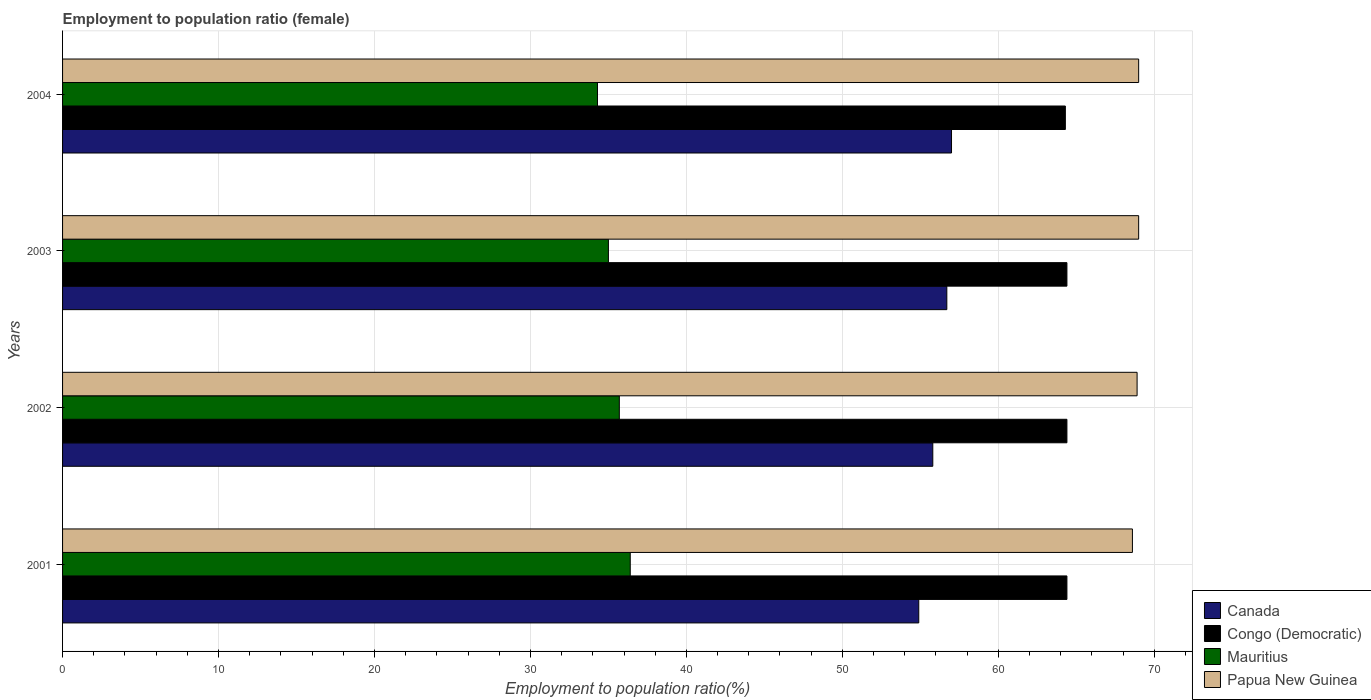How many different coloured bars are there?
Offer a very short reply. 4. Are the number of bars per tick equal to the number of legend labels?
Make the answer very short. Yes. Are the number of bars on each tick of the Y-axis equal?
Give a very brief answer. Yes. How many bars are there on the 2nd tick from the top?
Your answer should be compact. 4. How many bars are there on the 4th tick from the bottom?
Your answer should be compact. 4. What is the label of the 3rd group of bars from the top?
Provide a short and direct response. 2002. In how many cases, is the number of bars for a given year not equal to the number of legend labels?
Give a very brief answer. 0. What is the employment to population ratio in Papua New Guinea in 2001?
Provide a short and direct response. 68.6. Across all years, what is the maximum employment to population ratio in Mauritius?
Provide a short and direct response. 36.4. Across all years, what is the minimum employment to population ratio in Papua New Guinea?
Your answer should be very brief. 68.6. What is the total employment to population ratio in Papua New Guinea in the graph?
Your answer should be very brief. 275.5. What is the difference between the employment to population ratio in Papua New Guinea in 2003 and that in 2004?
Ensure brevity in your answer.  0. What is the difference between the employment to population ratio in Papua New Guinea in 2001 and the employment to population ratio in Canada in 2003?
Your response must be concise. 11.9. What is the average employment to population ratio in Congo (Democratic) per year?
Your response must be concise. 64.38. In the year 2003, what is the difference between the employment to population ratio in Canada and employment to population ratio in Mauritius?
Give a very brief answer. 21.7. What is the ratio of the employment to population ratio in Congo (Democratic) in 2002 to that in 2003?
Make the answer very short. 1. What is the difference between the highest and the second highest employment to population ratio in Canada?
Your answer should be compact. 0.3. What is the difference between the highest and the lowest employment to population ratio in Papua New Guinea?
Your answer should be very brief. 0.4. In how many years, is the employment to population ratio in Papua New Guinea greater than the average employment to population ratio in Papua New Guinea taken over all years?
Offer a terse response. 3. Is it the case that in every year, the sum of the employment to population ratio in Congo (Democratic) and employment to population ratio in Mauritius is greater than the sum of employment to population ratio in Canada and employment to population ratio in Papua New Guinea?
Your answer should be very brief. Yes. What does the 2nd bar from the top in 2004 represents?
Provide a succinct answer. Mauritius. What does the 4th bar from the bottom in 2002 represents?
Offer a terse response. Papua New Guinea. How many bars are there?
Your response must be concise. 16. Are all the bars in the graph horizontal?
Offer a terse response. Yes. Does the graph contain any zero values?
Keep it short and to the point. No. Does the graph contain grids?
Your answer should be compact. Yes. How many legend labels are there?
Offer a very short reply. 4. What is the title of the graph?
Offer a very short reply. Employment to population ratio (female). What is the label or title of the X-axis?
Offer a terse response. Employment to population ratio(%). What is the Employment to population ratio(%) of Canada in 2001?
Offer a terse response. 54.9. What is the Employment to population ratio(%) of Congo (Democratic) in 2001?
Keep it short and to the point. 64.4. What is the Employment to population ratio(%) of Mauritius in 2001?
Offer a terse response. 36.4. What is the Employment to population ratio(%) of Papua New Guinea in 2001?
Offer a very short reply. 68.6. What is the Employment to population ratio(%) in Canada in 2002?
Ensure brevity in your answer.  55.8. What is the Employment to population ratio(%) of Congo (Democratic) in 2002?
Make the answer very short. 64.4. What is the Employment to population ratio(%) in Mauritius in 2002?
Ensure brevity in your answer.  35.7. What is the Employment to population ratio(%) of Papua New Guinea in 2002?
Your response must be concise. 68.9. What is the Employment to population ratio(%) of Canada in 2003?
Keep it short and to the point. 56.7. What is the Employment to population ratio(%) of Congo (Democratic) in 2003?
Your answer should be very brief. 64.4. What is the Employment to population ratio(%) in Papua New Guinea in 2003?
Your answer should be compact. 69. What is the Employment to population ratio(%) of Canada in 2004?
Make the answer very short. 57. What is the Employment to population ratio(%) of Congo (Democratic) in 2004?
Provide a short and direct response. 64.3. What is the Employment to population ratio(%) of Mauritius in 2004?
Provide a succinct answer. 34.3. Across all years, what is the maximum Employment to population ratio(%) in Canada?
Your answer should be compact. 57. Across all years, what is the maximum Employment to population ratio(%) in Congo (Democratic)?
Provide a short and direct response. 64.4. Across all years, what is the maximum Employment to population ratio(%) in Mauritius?
Give a very brief answer. 36.4. Across all years, what is the maximum Employment to population ratio(%) of Papua New Guinea?
Keep it short and to the point. 69. Across all years, what is the minimum Employment to population ratio(%) in Canada?
Offer a terse response. 54.9. Across all years, what is the minimum Employment to population ratio(%) in Congo (Democratic)?
Ensure brevity in your answer.  64.3. Across all years, what is the minimum Employment to population ratio(%) of Mauritius?
Provide a short and direct response. 34.3. Across all years, what is the minimum Employment to population ratio(%) of Papua New Guinea?
Offer a very short reply. 68.6. What is the total Employment to population ratio(%) in Canada in the graph?
Your answer should be very brief. 224.4. What is the total Employment to population ratio(%) of Congo (Democratic) in the graph?
Make the answer very short. 257.5. What is the total Employment to population ratio(%) in Mauritius in the graph?
Give a very brief answer. 141.4. What is the total Employment to population ratio(%) in Papua New Guinea in the graph?
Give a very brief answer. 275.5. What is the difference between the Employment to population ratio(%) of Papua New Guinea in 2001 and that in 2002?
Provide a succinct answer. -0.3. What is the difference between the Employment to population ratio(%) of Canada in 2001 and that in 2003?
Your response must be concise. -1.8. What is the difference between the Employment to population ratio(%) in Papua New Guinea in 2001 and that in 2003?
Offer a very short reply. -0.4. What is the difference between the Employment to population ratio(%) in Congo (Democratic) in 2001 and that in 2004?
Your answer should be very brief. 0.1. What is the difference between the Employment to population ratio(%) of Mauritius in 2002 and that in 2003?
Make the answer very short. 0.7. What is the difference between the Employment to population ratio(%) of Papua New Guinea in 2002 and that in 2003?
Your answer should be compact. -0.1. What is the difference between the Employment to population ratio(%) of Canada in 2002 and that in 2004?
Ensure brevity in your answer.  -1.2. What is the difference between the Employment to population ratio(%) of Congo (Democratic) in 2002 and that in 2004?
Keep it short and to the point. 0.1. What is the difference between the Employment to population ratio(%) in Mauritius in 2002 and that in 2004?
Offer a terse response. 1.4. What is the difference between the Employment to population ratio(%) of Canada in 2003 and that in 2004?
Offer a very short reply. -0.3. What is the difference between the Employment to population ratio(%) in Mauritius in 2003 and that in 2004?
Offer a very short reply. 0.7. What is the difference between the Employment to population ratio(%) in Canada in 2001 and the Employment to population ratio(%) in Congo (Democratic) in 2002?
Offer a terse response. -9.5. What is the difference between the Employment to population ratio(%) of Canada in 2001 and the Employment to population ratio(%) of Papua New Guinea in 2002?
Offer a terse response. -14. What is the difference between the Employment to population ratio(%) of Congo (Democratic) in 2001 and the Employment to population ratio(%) of Mauritius in 2002?
Your answer should be very brief. 28.7. What is the difference between the Employment to population ratio(%) in Congo (Democratic) in 2001 and the Employment to population ratio(%) in Papua New Guinea in 2002?
Make the answer very short. -4.5. What is the difference between the Employment to population ratio(%) of Mauritius in 2001 and the Employment to population ratio(%) of Papua New Guinea in 2002?
Provide a succinct answer. -32.5. What is the difference between the Employment to population ratio(%) of Canada in 2001 and the Employment to population ratio(%) of Papua New Guinea in 2003?
Make the answer very short. -14.1. What is the difference between the Employment to population ratio(%) in Congo (Democratic) in 2001 and the Employment to population ratio(%) in Mauritius in 2003?
Provide a short and direct response. 29.4. What is the difference between the Employment to population ratio(%) of Congo (Democratic) in 2001 and the Employment to population ratio(%) of Papua New Guinea in 2003?
Provide a succinct answer. -4.6. What is the difference between the Employment to population ratio(%) in Mauritius in 2001 and the Employment to population ratio(%) in Papua New Guinea in 2003?
Your answer should be compact. -32.6. What is the difference between the Employment to population ratio(%) of Canada in 2001 and the Employment to population ratio(%) of Mauritius in 2004?
Offer a very short reply. 20.6. What is the difference between the Employment to population ratio(%) of Canada in 2001 and the Employment to population ratio(%) of Papua New Guinea in 2004?
Make the answer very short. -14.1. What is the difference between the Employment to population ratio(%) of Congo (Democratic) in 2001 and the Employment to population ratio(%) of Mauritius in 2004?
Provide a succinct answer. 30.1. What is the difference between the Employment to population ratio(%) of Mauritius in 2001 and the Employment to population ratio(%) of Papua New Guinea in 2004?
Provide a succinct answer. -32.6. What is the difference between the Employment to population ratio(%) of Canada in 2002 and the Employment to population ratio(%) of Congo (Democratic) in 2003?
Give a very brief answer. -8.6. What is the difference between the Employment to population ratio(%) of Canada in 2002 and the Employment to population ratio(%) of Mauritius in 2003?
Ensure brevity in your answer.  20.8. What is the difference between the Employment to population ratio(%) of Congo (Democratic) in 2002 and the Employment to population ratio(%) of Mauritius in 2003?
Offer a very short reply. 29.4. What is the difference between the Employment to population ratio(%) of Congo (Democratic) in 2002 and the Employment to population ratio(%) of Papua New Guinea in 2003?
Keep it short and to the point. -4.6. What is the difference between the Employment to population ratio(%) of Mauritius in 2002 and the Employment to population ratio(%) of Papua New Guinea in 2003?
Your answer should be very brief. -33.3. What is the difference between the Employment to population ratio(%) of Canada in 2002 and the Employment to population ratio(%) of Congo (Democratic) in 2004?
Your answer should be very brief. -8.5. What is the difference between the Employment to population ratio(%) of Congo (Democratic) in 2002 and the Employment to population ratio(%) of Mauritius in 2004?
Your answer should be very brief. 30.1. What is the difference between the Employment to population ratio(%) of Congo (Democratic) in 2002 and the Employment to population ratio(%) of Papua New Guinea in 2004?
Ensure brevity in your answer.  -4.6. What is the difference between the Employment to population ratio(%) of Mauritius in 2002 and the Employment to population ratio(%) of Papua New Guinea in 2004?
Provide a short and direct response. -33.3. What is the difference between the Employment to population ratio(%) of Canada in 2003 and the Employment to population ratio(%) of Mauritius in 2004?
Ensure brevity in your answer.  22.4. What is the difference between the Employment to population ratio(%) in Canada in 2003 and the Employment to population ratio(%) in Papua New Guinea in 2004?
Your answer should be very brief. -12.3. What is the difference between the Employment to population ratio(%) of Congo (Democratic) in 2003 and the Employment to population ratio(%) of Mauritius in 2004?
Provide a succinct answer. 30.1. What is the difference between the Employment to population ratio(%) in Mauritius in 2003 and the Employment to population ratio(%) in Papua New Guinea in 2004?
Offer a terse response. -34. What is the average Employment to population ratio(%) in Canada per year?
Keep it short and to the point. 56.1. What is the average Employment to population ratio(%) in Congo (Democratic) per year?
Your response must be concise. 64.38. What is the average Employment to population ratio(%) of Mauritius per year?
Provide a short and direct response. 35.35. What is the average Employment to population ratio(%) of Papua New Guinea per year?
Make the answer very short. 68.88. In the year 2001, what is the difference between the Employment to population ratio(%) in Canada and Employment to population ratio(%) in Mauritius?
Ensure brevity in your answer.  18.5. In the year 2001, what is the difference between the Employment to population ratio(%) of Canada and Employment to population ratio(%) of Papua New Guinea?
Keep it short and to the point. -13.7. In the year 2001, what is the difference between the Employment to population ratio(%) in Congo (Democratic) and Employment to population ratio(%) in Papua New Guinea?
Ensure brevity in your answer.  -4.2. In the year 2001, what is the difference between the Employment to population ratio(%) of Mauritius and Employment to population ratio(%) of Papua New Guinea?
Your answer should be very brief. -32.2. In the year 2002, what is the difference between the Employment to population ratio(%) in Canada and Employment to population ratio(%) in Mauritius?
Make the answer very short. 20.1. In the year 2002, what is the difference between the Employment to population ratio(%) of Congo (Democratic) and Employment to population ratio(%) of Mauritius?
Provide a short and direct response. 28.7. In the year 2002, what is the difference between the Employment to population ratio(%) of Mauritius and Employment to population ratio(%) of Papua New Guinea?
Make the answer very short. -33.2. In the year 2003, what is the difference between the Employment to population ratio(%) in Canada and Employment to population ratio(%) in Mauritius?
Offer a very short reply. 21.7. In the year 2003, what is the difference between the Employment to population ratio(%) in Congo (Democratic) and Employment to population ratio(%) in Mauritius?
Your response must be concise. 29.4. In the year 2003, what is the difference between the Employment to population ratio(%) of Congo (Democratic) and Employment to population ratio(%) of Papua New Guinea?
Your answer should be compact. -4.6. In the year 2003, what is the difference between the Employment to population ratio(%) in Mauritius and Employment to population ratio(%) in Papua New Guinea?
Provide a short and direct response. -34. In the year 2004, what is the difference between the Employment to population ratio(%) in Canada and Employment to population ratio(%) in Mauritius?
Offer a very short reply. 22.7. In the year 2004, what is the difference between the Employment to population ratio(%) of Canada and Employment to population ratio(%) of Papua New Guinea?
Offer a very short reply. -12. In the year 2004, what is the difference between the Employment to population ratio(%) in Congo (Democratic) and Employment to population ratio(%) in Mauritius?
Provide a succinct answer. 30. In the year 2004, what is the difference between the Employment to population ratio(%) of Mauritius and Employment to population ratio(%) of Papua New Guinea?
Offer a terse response. -34.7. What is the ratio of the Employment to population ratio(%) of Canada in 2001 to that in 2002?
Make the answer very short. 0.98. What is the ratio of the Employment to population ratio(%) of Mauritius in 2001 to that in 2002?
Ensure brevity in your answer.  1.02. What is the ratio of the Employment to population ratio(%) of Papua New Guinea in 2001 to that in 2002?
Ensure brevity in your answer.  1. What is the ratio of the Employment to population ratio(%) in Canada in 2001 to that in 2003?
Make the answer very short. 0.97. What is the ratio of the Employment to population ratio(%) in Canada in 2001 to that in 2004?
Make the answer very short. 0.96. What is the ratio of the Employment to population ratio(%) in Congo (Democratic) in 2001 to that in 2004?
Ensure brevity in your answer.  1. What is the ratio of the Employment to population ratio(%) of Mauritius in 2001 to that in 2004?
Make the answer very short. 1.06. What is the ratio of the Employment to population ratio(%) of Canada in 2002 to that in 2003?
Keep it short and to the point. 0.98. What is the ratio of the Employment to population ratio(%) in Mauritius in 2002 to that in 2003?
Keep it short and to the point. 1.02. What is the ratio of the Employment to population ratio(%) of Canada in 2002 to that in 2004?
Provide a short and direct response. 0.98. What is the ratio of the Employment to population ratio(%) in Congo (Democratic) in 2002 to that in 2004?
Your answer should be compact. 1. What is the ratio of the Employment to population ratio(%) in Mauritius in 2002 to that in 2004?
Provide a short and direct response. 1.04. What is the ratio of the Employment to population ratio(%) in Papua New Guinea in 2002 to that in 2004?
Give a very brief answer. 1. What is the ratio of the Employment to population ratio(%) in Mauritius in 2003 to that in 2004?
Your answer should be very brief. 1.02. What is the difference between the highest and the second highest Employment to population ratio(%) in Papua New Guinea?
Provide a succinct answer. 0. What is the difference between the highest and the lowest Employment to population ratio(%) in Canada?
Your response must be concise. 2.1. What is the difference between the highest and the lowest Employment to population ratio(%) of Congo (Democratic)?
Your response must be concise. 0.1. What is the difference between the highest and the lowest Employment to population ratio(%) of Mauritius?
Offer a very short reply. 2.1. 